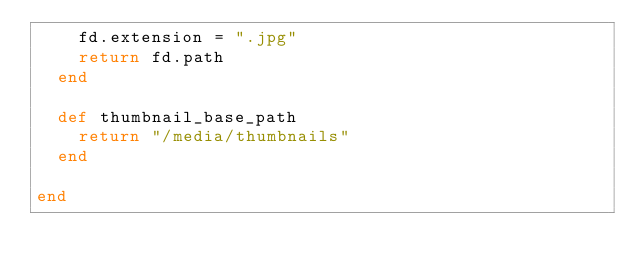<code> <loc_0><loc_0><loc_500><loc_500><_Ruby_>    fd.extension = ".jpg"
    return fd.path
  end

  def thumbnail_base_path
    return "/media/thumbnails"
  end

end
</code> 